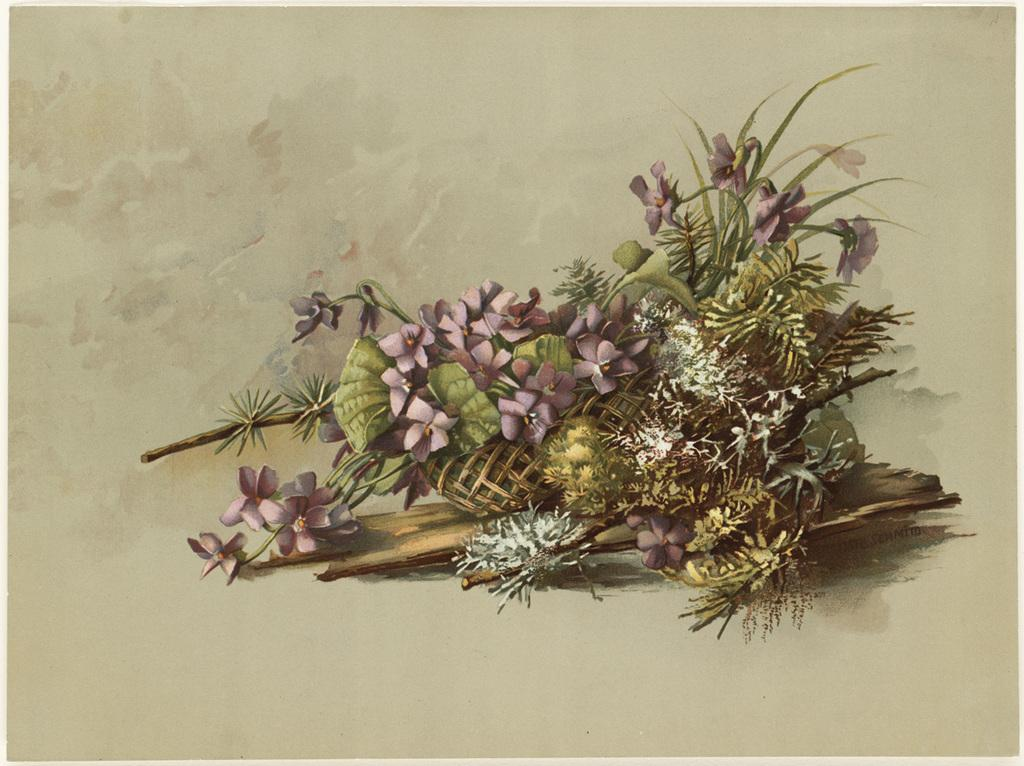What is the main subject of the image? The main subject of the image is a picture of a bunch of flowers. What is the picture printed on? The picture is on a paper. What type of attention is the church receiving in the image? There is no church present in the image, so it cannot receive any attention. 